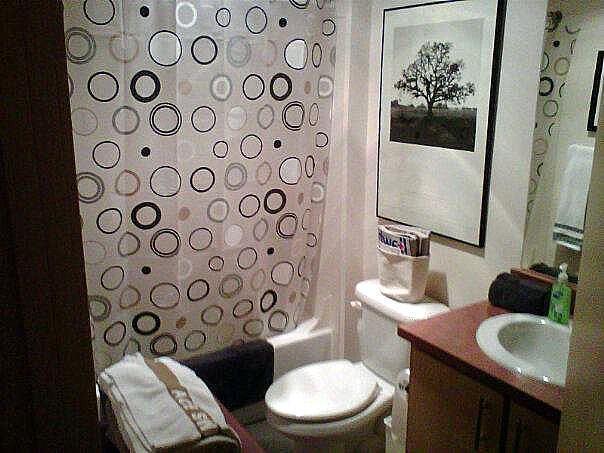How many sinks are in the picture?
Give a very brief answer. 1. How many people are cutting cake?
Give a very brief answer. 0. 